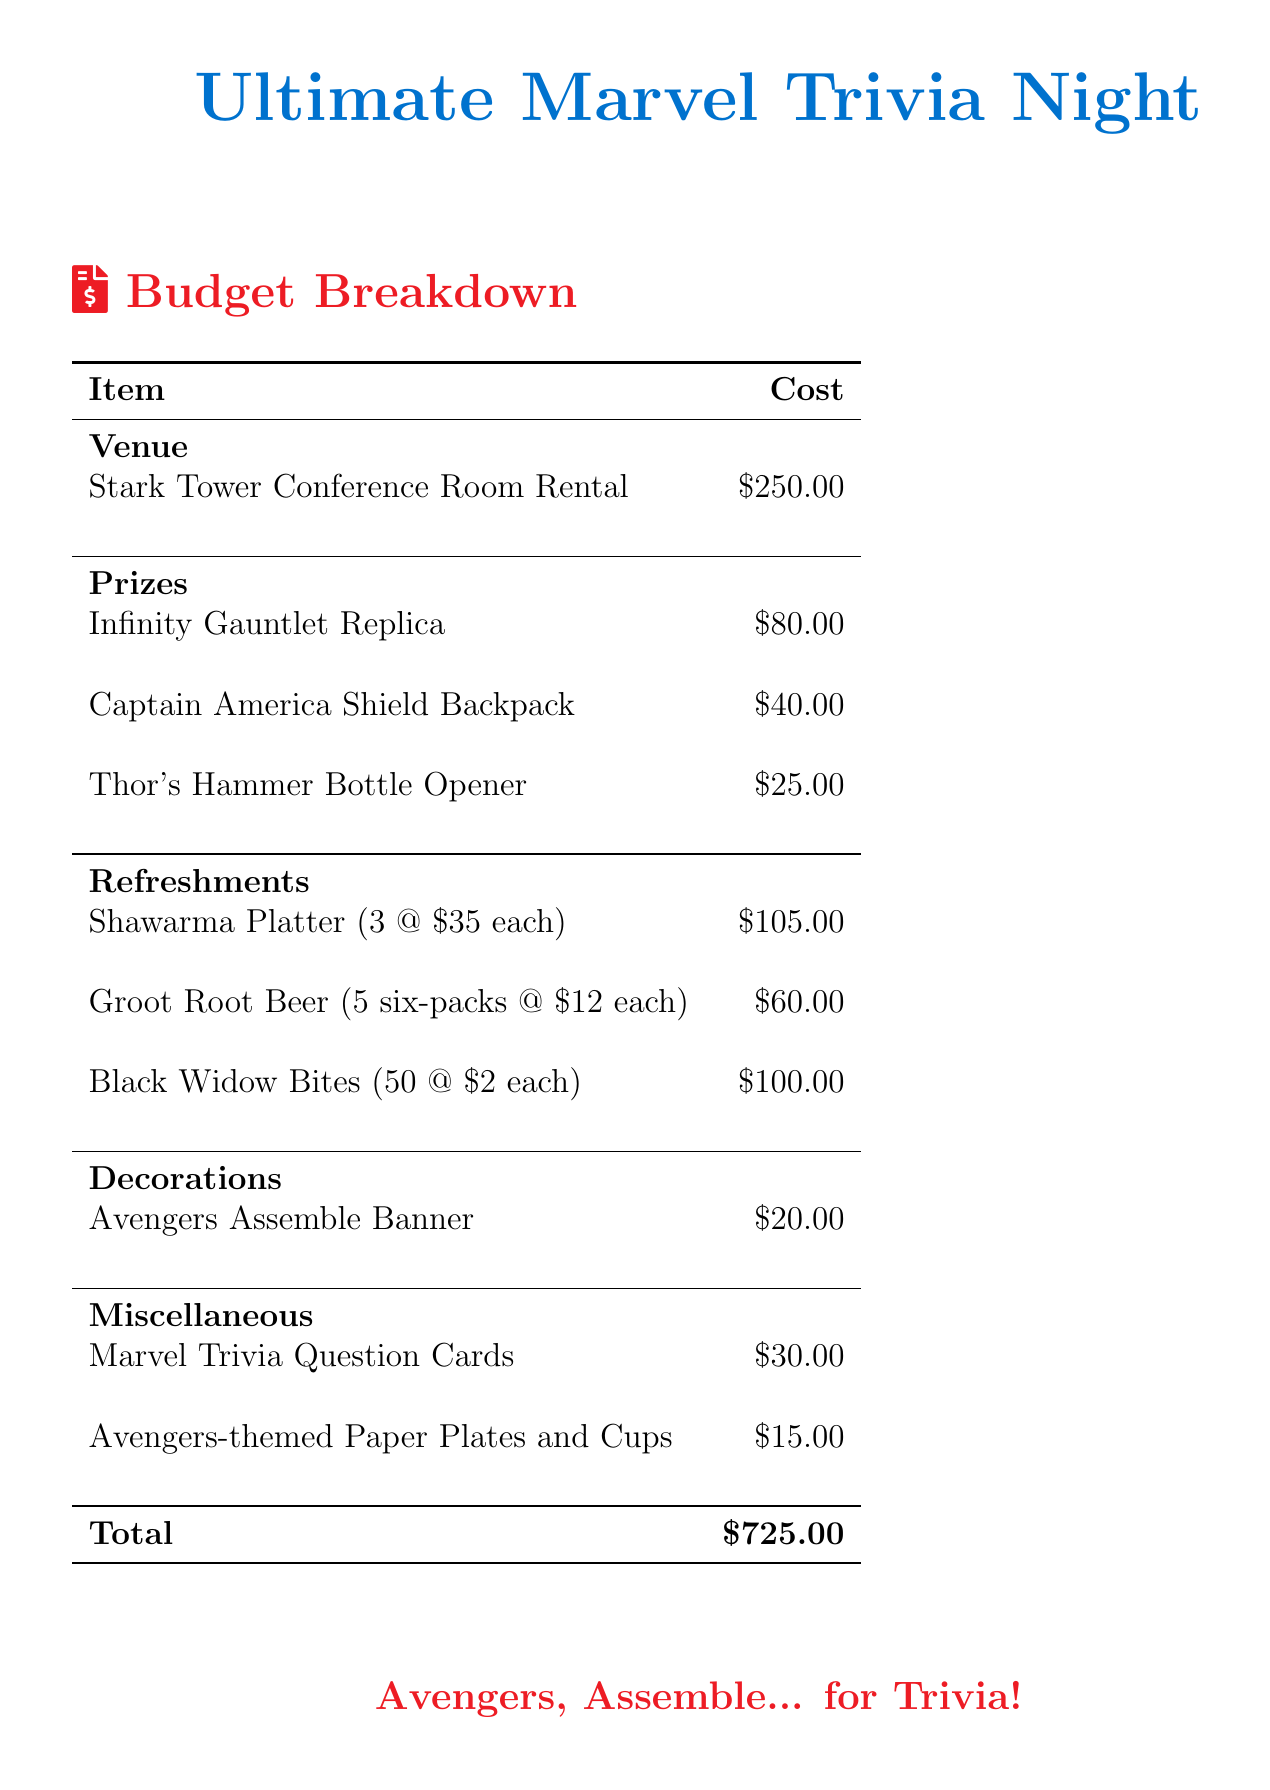What is the total cost of the trivia night? The total cost is the sum of all expenses listed in the document, which is $725.00.
Answer: $725.00 How much does the Stark Tower Conference Room Rental cost? The cost listed for the venue rental is $250.00.
Answer: $250.00 What is the cost of the Infinity Gauntlet Replica? The cost for the Infinity Gauntlet Replica prize is listed as $80.00.
Answer: $80.00 How many Groot Root Beer six-packs are included? The document mentions that there are 5 six-packs of Groot Root Beer.
Answer: 5 six-packs What is the total cost of refreshment items? The total cost of all refreshments can be calculated as $105 + $60 + $100 = $265.00.
Answer: $265.00 What item costs the least among the prizes? Among the prizes, the Thor's Hammer Bottle Opener has the lowest cost at $25.00.
Answer: $25.00 How much do the Avengers-themed Paper Plates and Cups cost? The cost for the Avengers-themed Paper Plates and Cups is listed as $15.00.
Answer: $15.00 What is included in the decorations category? The only item mentioned under decorations is the Avengers Assemble Banner, which costs $20.00.
Answer: Avengers Assemble Banner What is the price of the shawarma platter? Each shawarma platter costs $35, and there are 3 platters, totaling $105.00.
Answer: $35.00 